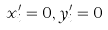<formula> <loc_0><loc_0><loc_500><loc_500>x _ { i } ^ { \prime } = 0 , y _ { i } ^ { \prime } = 0</formula> 